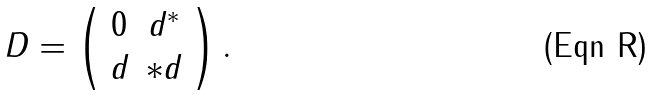Convert formula to latex. <formula><loc_0><loc_0><loc_500><loc_500>D = \left ( \begin{array} { c c } 0 & d ^ { * } \\ d & * d \end{array} \right ) .</formula> 